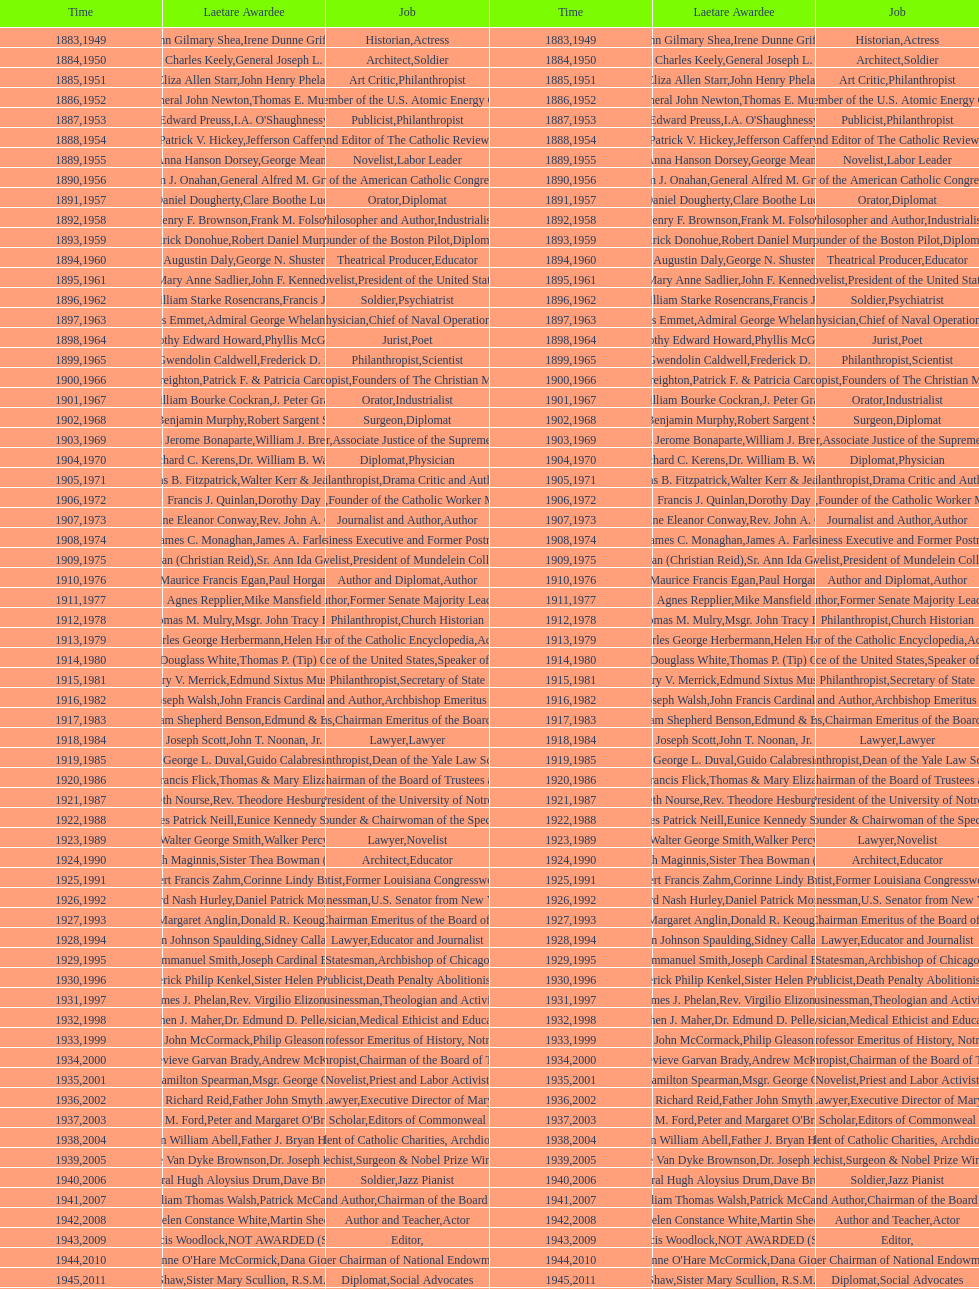How many lawyers have won the award between 1883 and 2014? 5. 